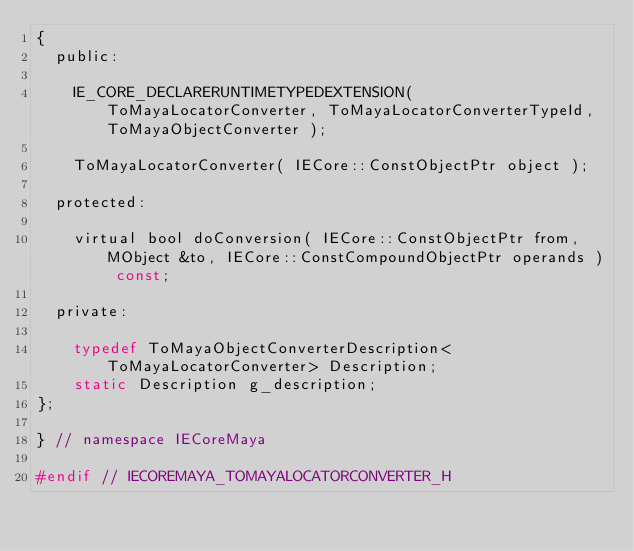Convert code to text. <code><loc_0><loc_0><loc_500><loc_500><_C_>{
	public:

		IE_CORE_DECLARERUNTIMETYPEDEXTENSION( ToMayaLocatorConverter, ToMayaLocatorConverterTypeId, ToMayaObjectConverter );

		ToMayaLocatorConverter( IECore::ConstObjectPtr object );

	protected:

		virtual bool doConversion( IECore::ConstObjectPtr from, MObject &to, IECore::ConstCompoundObjectPtr operands ) const;

	private:

		typedef ToMayaObjectConverterDescription<ToMayaLocatorConverter> Description;
		static Description g_description;
};

} // namespace IECoreMaya

#endif // IECOREMAYA_TOMAYALOCATORCONVERTER_H
</code> 